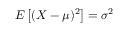Convert formula to latex. <formula><loc_0><loc_0><loc_500><loc_500>E \left [ ( X - \mu ) ^ { 2 } \right ] = \sigma ^ { 2 }</formula> 